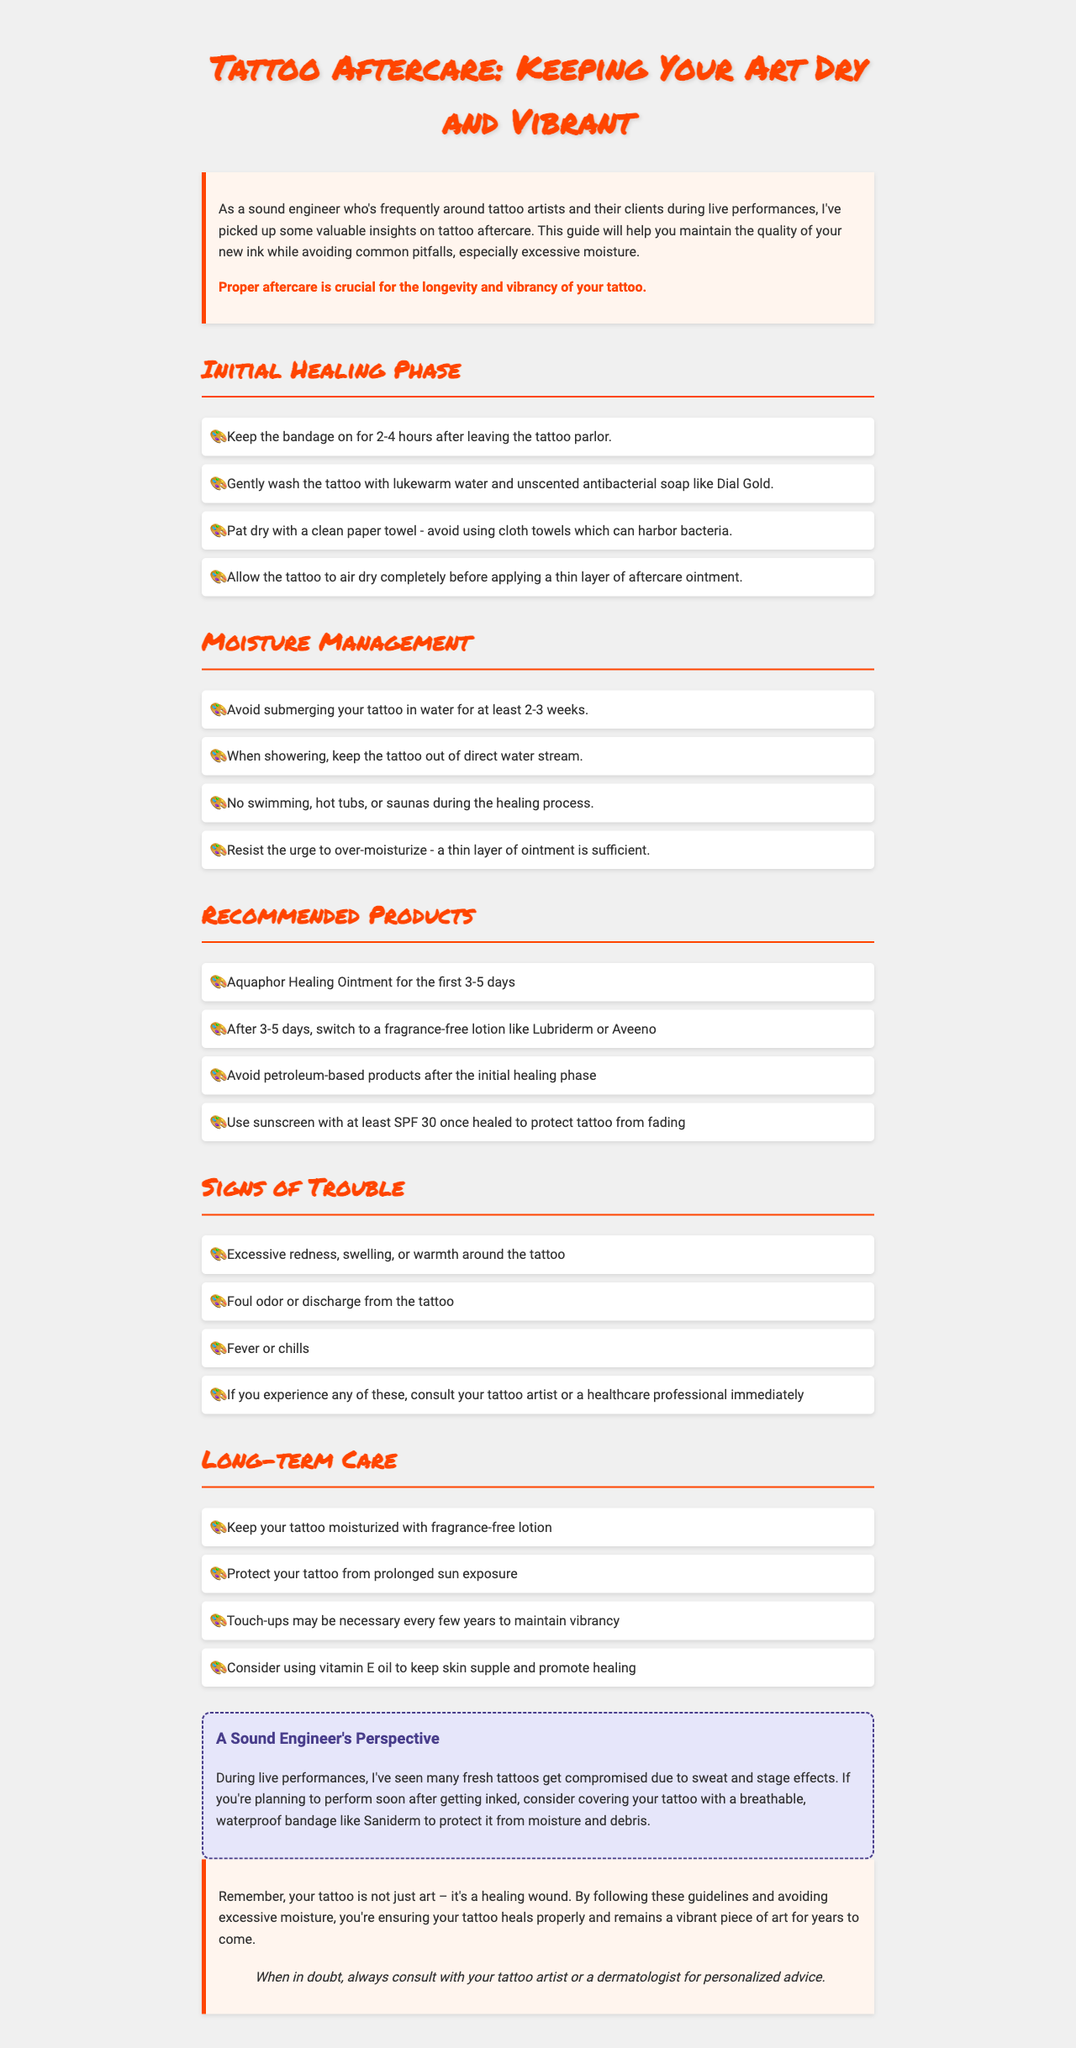what is the title of the brochure? The title is presented at the top of the document, emphasizing tattoo aftercare.
Answer: Tattoo Aftercare: Keeping Your Art Dry and Vibrant how long should the bandage stay on after leaving the tattoo parlor? The document specifies the duration for keeping the bandage on in the initial healing phase.
Answer: 2-4 hours what should you use to wash your tattoo? The document recommends a specific type of soap for gently washing the tattoo.
Answer: Unscented antibacterial soap how long should you avoid submerging your tattoo in water? The document provides a time frame for avoiding submersion after getting a tattoo.
Answer: 2-3 weeks what products are recommended for the first 3-5 days? The brochure lists specific ointments for the initial aftercare period.
Answer: Aquaphor Healing Ointment what is a common sign of trouble during the healing process? The document outlines symptoms that should prompt consultation with a professional.
Answer: Excessive redness what is a sound engineer's tip for protecting a fresh tattoo during performances? The document recommends a specific type of bandage for sound engineers to use while performing.
Answer: A breathable, waterproof bandage like Saniderm when might touch-ups be necessary for a tattoo? The brochure mentions care to ensure the longevity of a tattoo and the need for the maintenance procedure.
Answer: Every few years what is the final tip provided in the conclusion? The document concludes with advice regarding personal consultations for aftercare.
Answer: When in doubt, always consult with your tattoo artist or a dermatologist for personalized advice 